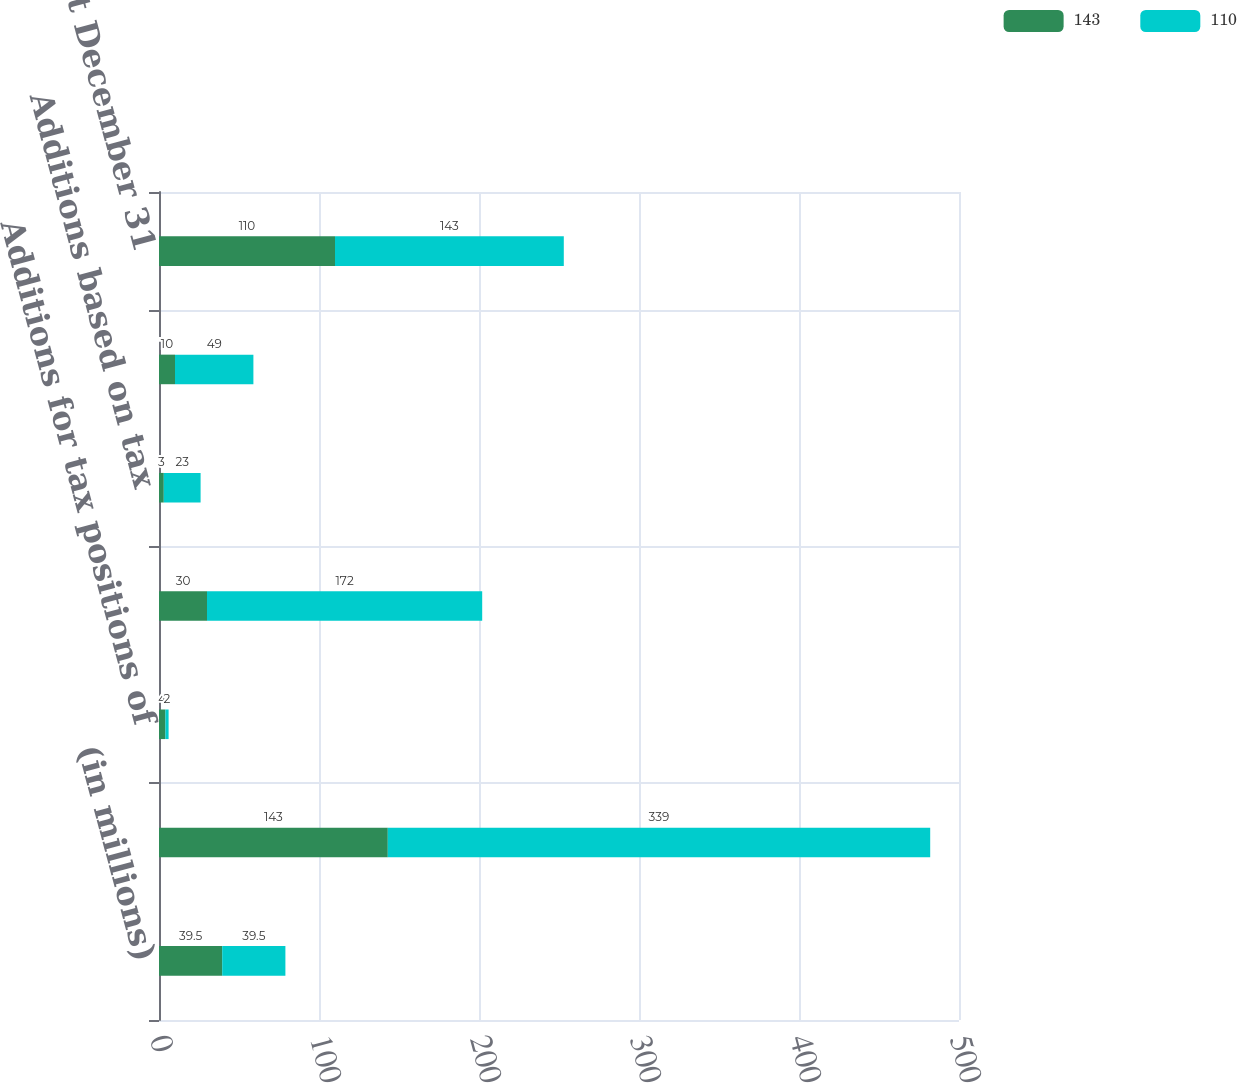Convert chart to OTSL. <chart><loc_0><loc_0><loc_500><loc_500><stacked_bar_chart><ecel><fcel>(in millions)<fcel>Balance at January 1<fcel>Additions for tax positions of<fcel>Reductions for tax positions<fcel>Additions based on tax<fcel>Reductions based on tax<fcel>Balance at December 31<nl><fcel>143<fcel>39.5<fcel>143<fcel>4<fcel>30<fcel>3<fcel>10<fcel>110<nl><fcel>110<fcel>39.5<fcel>339<fcel>2<fcel>172<fcel>23<fcel>49<fcel>143<nl></chart> 